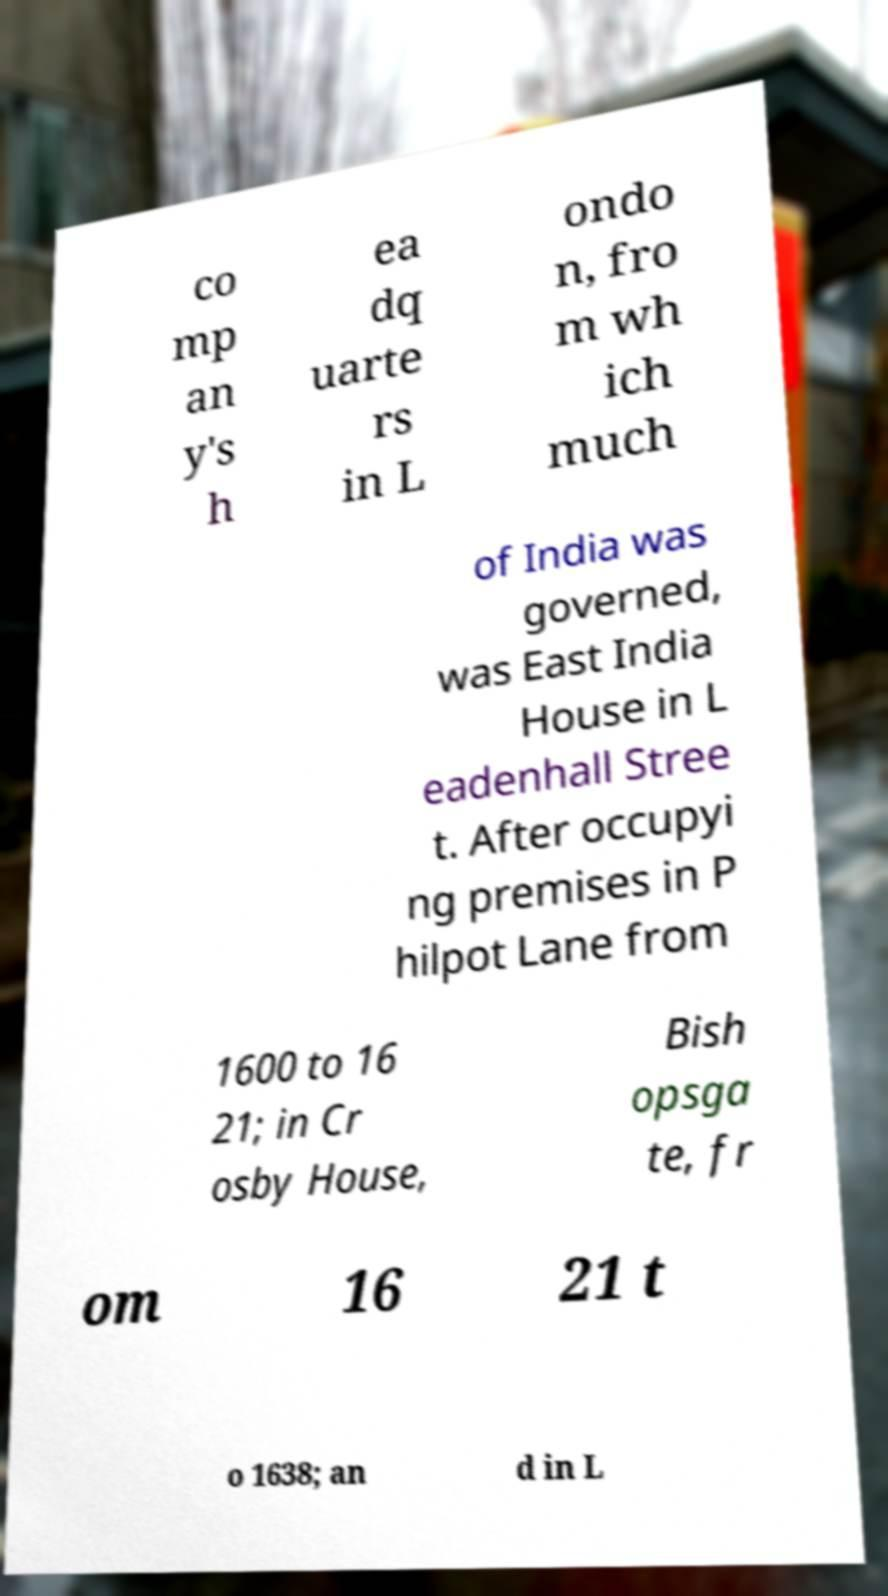Could you extract and type out the text from this image? co mp an y's h ea dq uarte rs in L ondo n, fro m wh ich much of India was governed, was East India House in L eadenhall Stree t. After occupyi ng premises in P hilpot Lane from 1600 to 16 21; in Cr osby House, Bish opsga te, fr om 16 21 t o 1638; an d in L 